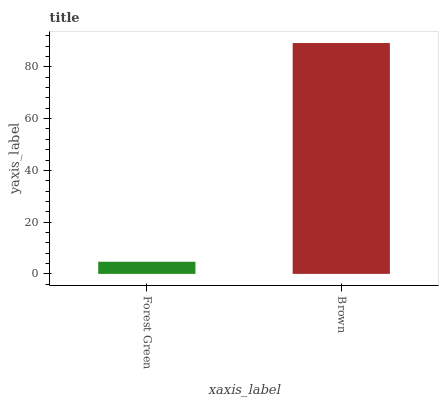Is Forest Green the minimum?
Answer yes or no. Yes. Is Brown the maximum?
Answer yes or no. Yes. Is Brown the minimum?
Answer yes or no. No. Is Brown greater than Forest Green?
Answer yes or no. Yes. Is Forest Green less than Brown?
Answer yes or no. Yes. Is Forest Green greater than Brown?
Answer yes or no. No. Is Brown less than Forest Green?
Answer yes or no. No. Is Brown the high median?
Answer yes or no. Yes. Is Forest Green the low median?
Answer yes or no. Yes. Is Forest Green the high median?
Answer yes or no. No. Is Brown the low median?
Answer yes or no. No. 